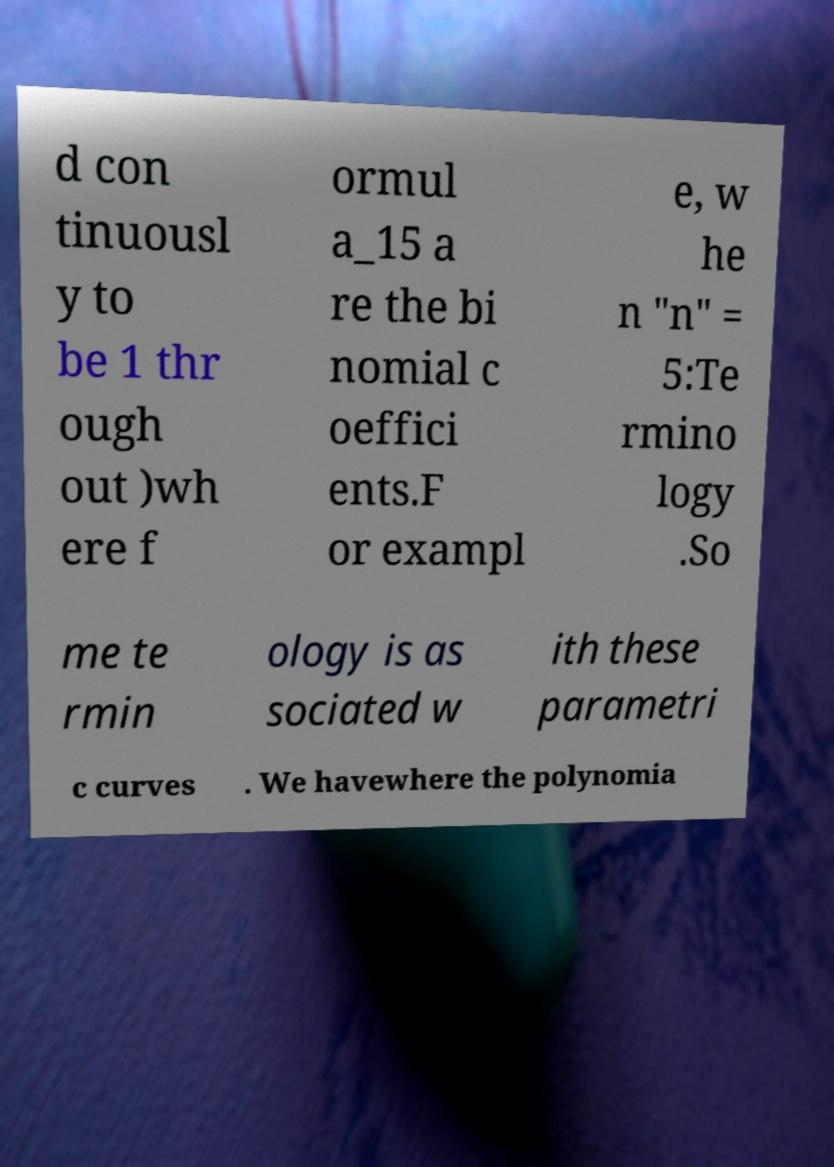Please identify and transcribe the text found in this image. d con tinuousl y to be 1 thr ough out )wh ere f ormul a_15 a re the bi nomial c oeffici ents.F or exampl e, w he n "n" = 5:Te rmino logy .So me te rmin ology is as sociated w ith these parametri c curves . We havewhere the polynomia 